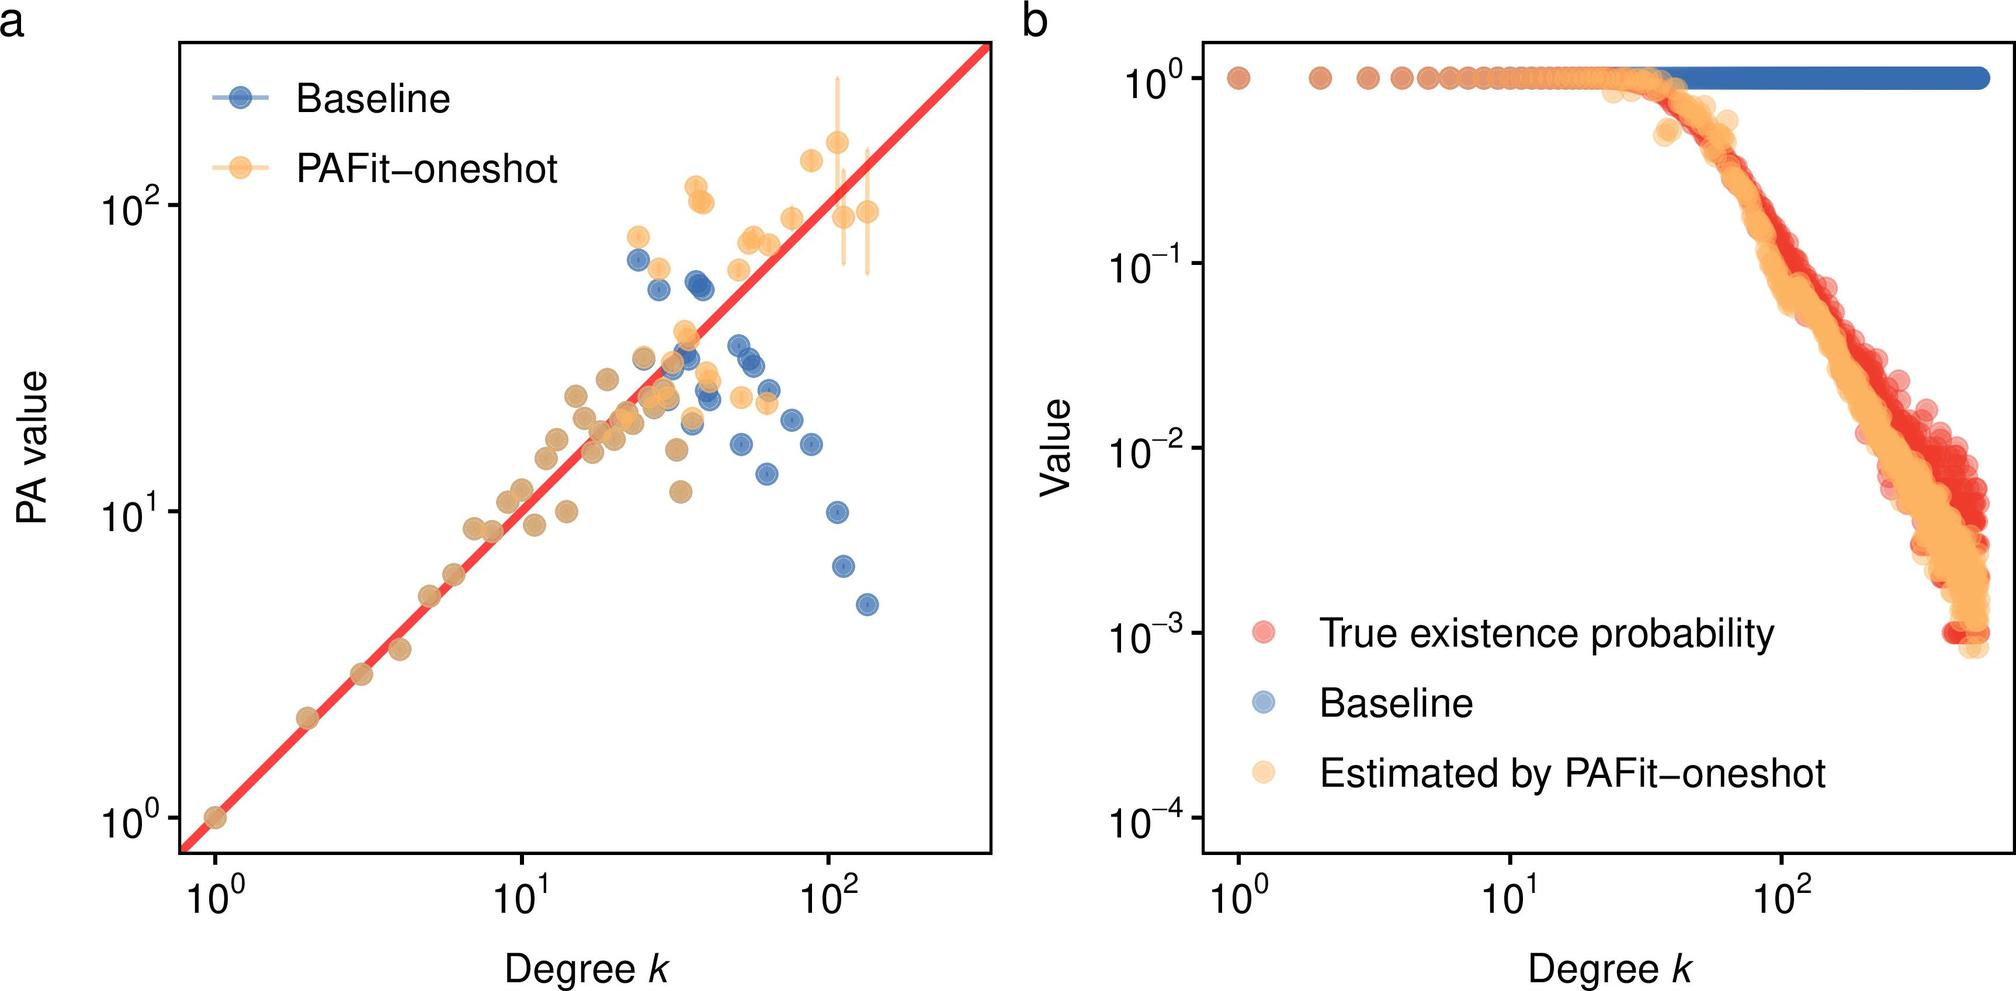How might the baseline and PAFit-oneshot estimates seen in figure b assist in improving predictive analytics? The presence of both baseline and PAFit-oneshot estimates in figure b provides a comparative analysis that is invaluable for improving predictive analytics. By examining where PAFit-oneshot aligns closely with the baseline and where it diverges, analysts can identify strengths and weaknesses in the current modeling approach. Enhancements can be targeted to areas where the estimates deviate from expected values, thereby fine-tuning the model's accuracy. This iterative process of comparison, analysis, and adjustment is fundamental to evolving and refining predictive models to better capture the underlying data behavior. 